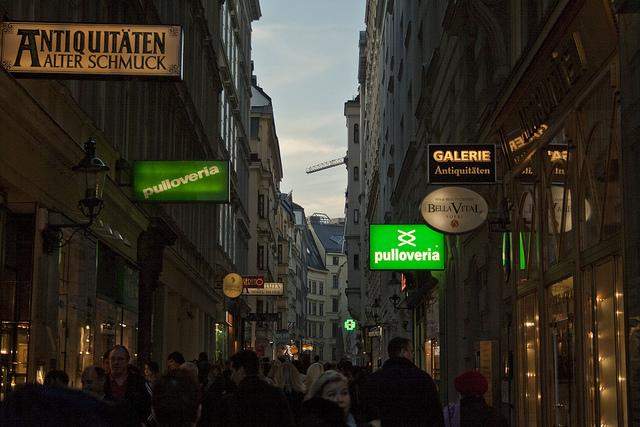Where is Pulloveria based?

Choices:
A) hamburg
B) vienna
C) new york
D) toronto vienna 